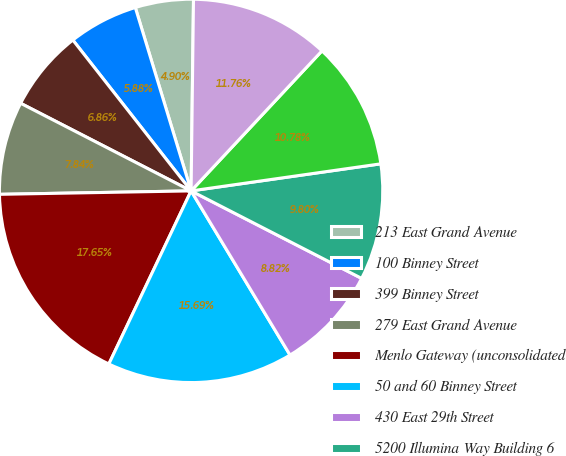<chart> <loc_0><loc_0><loc_500><loc_500><pie_chart><fcel>213 East Grand Avenue<fcel>100 Binney Street<fcel>399 Binney Street<fcel>279 East Grand Avenue<fcel>Menlo Gateway (unconsolidated<fcel>50 and 60 Binney Street<fcel>430 East 29th Street<fcel>5200 Illumina Way Building 6<fcel>4796 Executive Drive<fcel>360 Longwood Avenue<nl><fcel>4.9%<fcel>5.88%<fcel>6.86%<fcel>7.84%<fcel>17.65%<fcel>15.69%<fcel>8.82%<fcel>9.8%<fcel>10.78%<fcel>11.76%<nl></chart> 